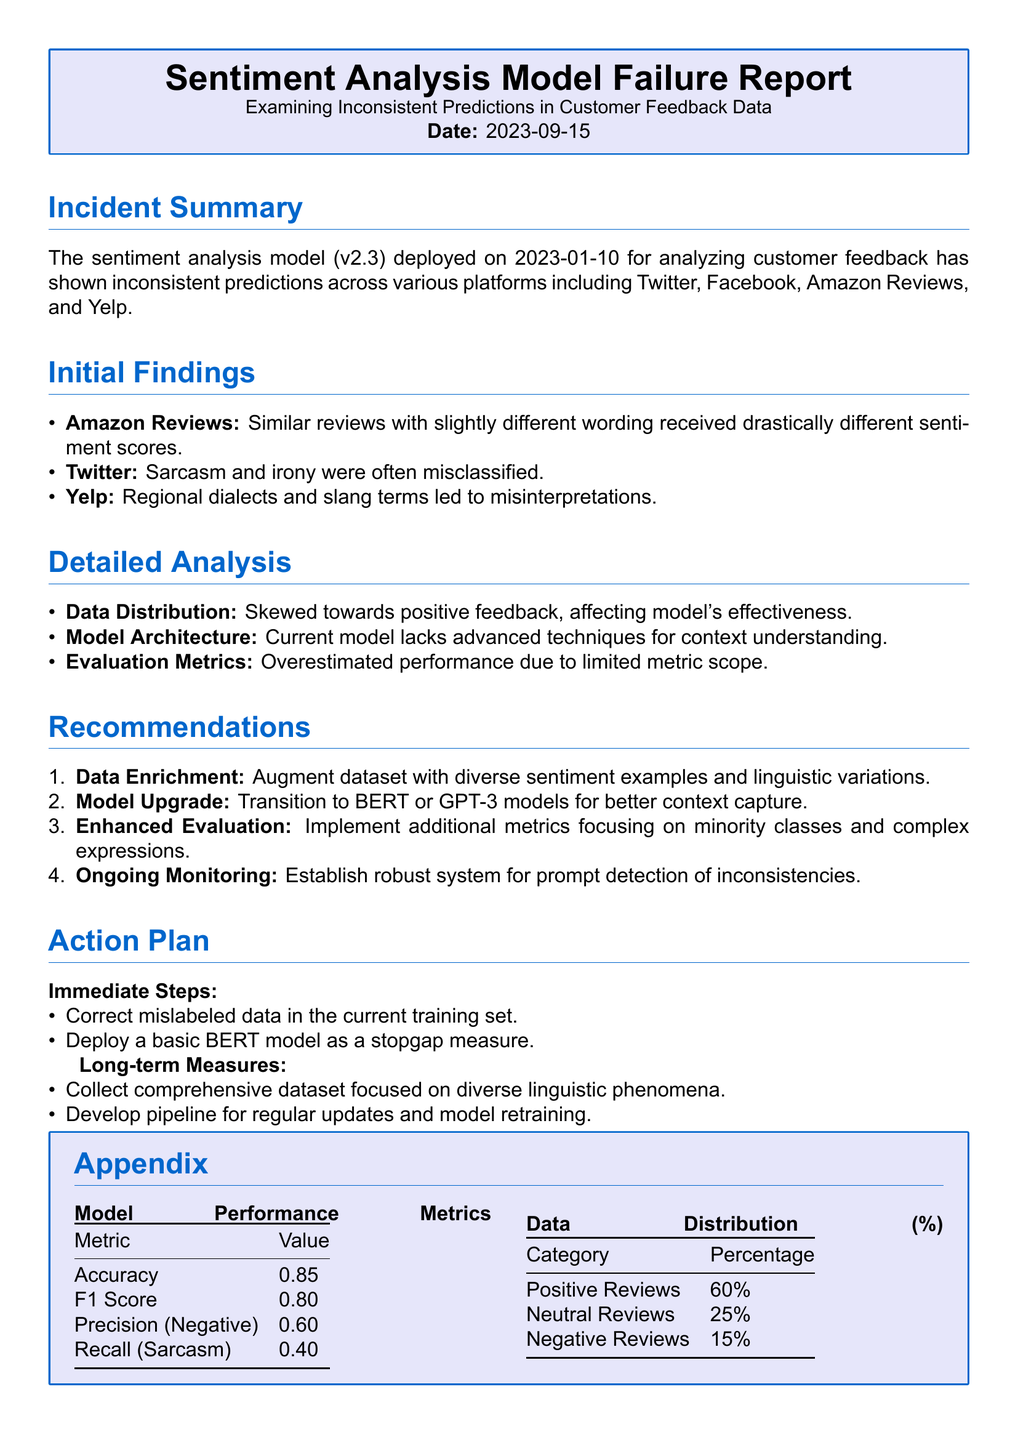what is the version of the sentiment analysis model? The report mentions that the deployed sentiment analysis model version is v2.3.
Answer: v2.3 what is the date of the incident report? The report specifies the date as 2023-09-15.
Answer: 2023-09-15 what percentage of reviews were positive according to the data distribution? The data distribution shows that 60% of the reviews were positive.
Answer: 60% what is the recall value for sarcasm? The document lists the recall for sarcasm as 0.40.
Answer: 0.40 which platform had issues with sarcasm and irony? The report indicates that sarcasm and irony were misclassified on Twitter.
Answer: Twitter what is the primary recommendation for improving the model? The most highlighted recommendation is to transition to BERT or GPT-3 models.
Answer: BERT or GPT-3 how many immediate steps are listed in the action plan? The action plan contains two immediate steps for correction and deployment.
Answer: 2 what was the accuracy of the model? The model's accuracy is reported to be 0.85 in the performance metrics section.
Answer: 0.85 what type of analysis was conducted in the report? The report conducted a detailed analysis of inconsistent predictions in customer feedback data.
Answer: detailed analysis 